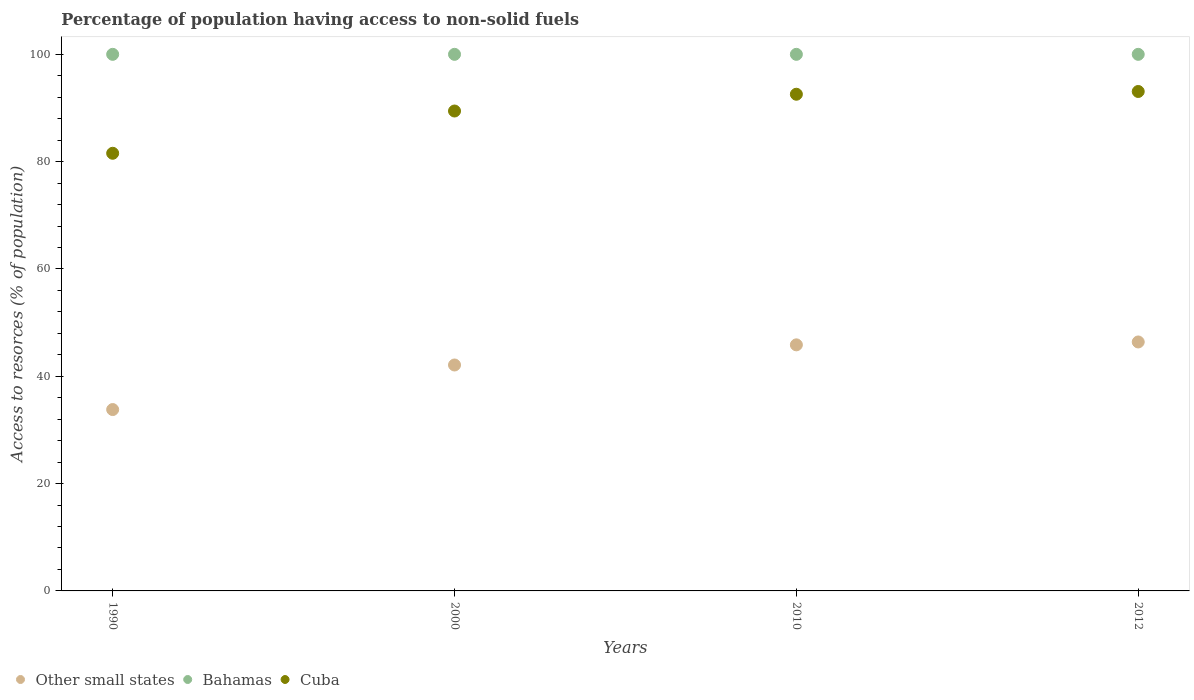Is the number of dotlines equal to the number of legend labels?
Your answer should be very brief. Yes. What is the percentage of population having access to non-solid fuels in Other small states in 1990?
Make the answer very short. 33.8. Across all years, what is the maximum percentage of population having access to non-solid fuels in Other small states?
Make the answer very short. 46.4. Across all years, what is the minimum percentage of population having access to non-solid fuels in Other small states?
Make the answer very short. 33.8. What is the total percentage of population having access to non-solid fuels in Other small states in the graph?
Provide a short and direct response. 168.16. What is the difference between the percentage of population having access to non-solid fuels in Bahamas in 1990 and that in 2010?
Your response must be concise. 0. What is the difference between the percentage of population having access to non-solid fuels in Bahamas in 2000 and the percentage of population having access to non-solid fuels in Cuba in 2010?
Your answer should be compact. 7.44. What is the average percentage of population having access to non-solid fuels in Bahamas per year?
Give a very brief answer. 100. In the year 2012, what is the difference between the percentage of population having access to non-solid fuels in Cuba and percentage of population having access to non-solid fuels in Other small states?
Provide a short and direct response. 46.68. What is the ratio of the percentage of population having access to non-solid fuels in Cuba in 2000 to that in 2010?
Offer a very short reply. 0.97. Is the percentage of population having access to non-solid fuels in Other small states in 1990 less than that in 2000?
Offer a terse response. Yes. What is the difference between the highest and the second highest percentage of population having access to non-solid fuels in Cuba?
Ensure brevity in your answer.  0.51. What is the difference between the highest and the lowest percentage of population having access to non-solid fuels in Bahamas?
Your answer should be very brief. 0. Is the sum of the percentage of population having access to non-solid fuels in Other small states in 2000 and 2010 greater than the maximum percentage of population having access to non-solid fuels in Bahamas across all years?
Your answer should be very brief. No. How many dotlines are there?
Offer a terse response. 3. What is the difference between two consecutive major ticks on the Y-axis?
Your response must be concise. 20. Are the values on the major ticks of Y-axis written in scientific E-notation?
Your answer should be compact. No. Does the graph contain any zero values?
Give a very brief answer. No. Does the graph contain grids?
Make the answer very short. No. Where does the legend appear in the graph?
Your answer should be compact. Bottom left. What is the title of the graph?
Your answer should be compact. Percentage of population having access to non-solid fuels. What is the label or title of the Y-axis?
Offer a terse response. Access to resorces (% of population). What is the Access to resorces (% of population) of Other small states in 1990?
Your response must be concise. 33.8. What is the Access to resorces (% of population) in Cuba in 1990?
Provide a short and direct response. 81.56. What is the Access to resorces (% of population) in Other small states in 2000?
Offer a terse response. 42.11. What is the Access to resorces (% of population) of Bahamas in 2000?
Provide a short and direct response. 100. What is the Access to resorces (% of population) of Cuba in 2000?
Ensure brevity in your answer.  89.44. What is the Access to resorces (% of population) of Other small states in 2010?
Ensure brevity in your answer.  45.86. What is the Access to resorces (% of population) of Bahamas in 2010?
Your answer should be compact. 100. What is the Access to resorces (% of population) of Cuba in 2010?
Your answer should be very brief. 92.56. What is the Access to resorces (% of population) in Other small states in 2012?
Offer a terse response. 46.4. What is the Access to resorces (% of population) in Bahamas in 2012?
Provide a short and direct response. 100. What is the Access to resorces (% of population) of Cuba in 2012?
Make the answer very short. 93.08. Across all years, what is the maximum Access to resorces (% of population) of Other small states?
Ensure brevity in your answer.  46.4. Across all years, what is the maximum Access to resorces (% of population) of Bahamas?
Keep it short and to the point. 100. Across all years, what is the maximum Access to resorces (% of population) in Cuba?
Offer a terse response. 93.08. Across all years, what is the minimum Access to resorces (% of population) of Other small states?
Your response must be concise. 33.8. Across all years, what is the minimum Access to resorces (% of population) of Bahamas?
Ensure brevity in your answer.  100. Across all years, what is the minimum Access to resorces (% of population) in Cuba?
Your response must be concise. 81.56. What is the total Access to resorces (% of population) in Other small states in the graph?
Provide a short and direct response. 168.16. What is the total Access to resorces (% of population) of Cuba in the graph?
Your answer should be very brief. 356.64. What is the difference between the Access to resorces (% of population) of Other small states in 1990 and that in 2000?
Your answer should be very brief. -8.31. What is the difference between the Access to resorces (% of population) in Bahamas in 1990 and that in 2000?
Keep it short and to the point. 0. What is the difference between the Access to resorces (% of population) of Cuba in 1990 and that in 2000?
Keep it short and to the point. -7.88. What is the difference between the Access to resorces (% of population) in Other small states in 1990 and that in 2010?
Make the answer very short. -12.06. What is the difference between the Access to resorces (% of population) of Cuba in 1990 and that in 2010?
Provide a succinct answer. -11. What is the difference between the Access to resorces (% of population) of Other small states in 1990 and that in 2012?
Ensure brevity in your answer.  -12.6. What is the difference between the Access to resorces (% of population) of Cuba in 1990 and that in 2012?
Provide a short and direct response. -11.52. What is the difference between the Access to resorces (% of population) in Other small states in 2000 and that in 2010?
Give a very brief answer. -3.75. What is the difference between the Access to resorces (% of population) of Cuba in 2000 and that in 2010?
Provide a succinct answer. -3.13. What is the difference between the Access to resorces (% of population) of Other small states in 2000 and that in 2012?
Offer a terse response. -4.29. What is the difference between the Access to resorces (% of population) in Bahamas in 2000 and that in 2012?
Provide a short and direct response. 0. What is the difference between the Access to resorces (% of population) of Cuba in 2000 and that in 2012?
Your answer should be very brief. -3.64. What is the difference between the Access to resorces (% of population) in Other small states in 2010 and that in 2012?
Your answer should be compact. -0.54. What is the difference between the Access to resorces (% of population) in Bahamas in 2010 and that in 2012?
Ensure brevity in your answer.  0. What is the difference between the Access to resorces (% of population) in Cuba in 2010 and that in 2012?
Offer a terse response. -0.51. What is the difference between the Access to resorces (% of population) in Other small states in 1990 and the Access to resorces (% of population) in Bahamas in 2000?
Offer a very short reply. -66.2. What is the difference between the Access to resorces (% of population) of Other small states in 1990 and the Access to resorces (% of population) of Cuba in 2000?
Ensure brevity in your answer.  -55.64. What is the difference between the Access to resorces (% of population) in Bahamas in 1990 and the Access to resorces (% of population) in Cuba in 2000?
Provide a succinct answer. 10.56. What is the difference between the Access to resorces (% of population) in Other small states in 1990 and the Access to resorces (% of population) in Bahamas in 2010?
Make the answer very short. -66.2. What is the difference between the Access to resorces (% of population) of Other small states in 1990 and the Access to resorces (% of population) of Cuba in 2010?
Ensure brevity in your answer.  -58.76. What is the difference between the Access to resorces (% of population) of Bahamas in 1990 and the Access to resorces (% of population) of Cuba in 2010?
Your response must be concise. 7.44. What is the difference between the Access to resorces (% of population) of Other small states in 1990 and the Access to resorces (% of population) of Bahamas in 2012?
Provide a short and direct response. -66.2. What is the difference between the Access to resorces (% of population) of Other small states in 1990 and the Access to resorces (% of population) of Cuba in 2012?
Your answer should be compact. -59.28. What is the difference between the Access to resorces (% of population) of Bahamas in 1990 and the Access to resorces (% of population) of Cuba in 2012?
Ensure brevity in your answer.  6.92. What is the difference between the Access to resorces (% of population) of Other small states in 2000 and the Access to resorces (% of population) of Bahamas in 2010?
Provide a succinct answer. -57.89. What is the difference between the Access to resorces (% of population) of Other small states in 2000 and the Access to resorces (% of population) of Cuba in 2010?
Provide a short and direct response. -50.46. What is the difference between the Access to resorces (% of population) in Bahamas in 2000 and the Access to resorces (% of population) in Cuba in 2010?
Give a very brief answer. 7.44. What is the difference between the Access to resorces (% of population) in Other small states in 2000 and the Access to resorces (% of population) in Bahamas in 2012?
Make the answer very short. -57.89. What is the difference between the Access to resorces (% of population) in Other small states in 2000 and the Access to resorces (% of population) in Cuba in 2012?
Provide a succinct answer. -50.97. What is the difference between the Access to resorces (% of population) of Bahamas in 2000 and the Access to resorces (% of population) of Cuba in 2012?
Give a very brief answer. 6.92. What is the difference between the Access to resorces (% of population) in Other small states in 2010 and the Access to resorces (% of population) in Bahamas in 2012?
Provide a short and direct response. -54.14. What is the difference between the Access to resorces (% of population) of Other small states in 2010 and the Access to resorces (% of population) of Cuba in 2012?
Give a very brief answer. -47.22. What is the difference between the Access to resorces (% of population) of Bahamas in 2010 and the Access to resorces (% of population) of Cuba in 2012?
Make the answer very short. 6.92. What is the average Access to resorces (% of population) of Other small states per year?
Your answer should be very brief. 42.04. What is the average Access to resorces (% of population) in Cuba per year?
Make the answer very short. 89.16. In the year 1990, what is the difference between the Access to resorces (% of population) of Other small states and Access to resorces (% of population) of Bahamas?
Offer a very short reply. -66.2. In the year 1990, what is the difference between the Access to resorces (% of population) in Other small states and Access to resorces (% of population) in Cuba?
Offer a very short reply. -47.76. In the year 1990, what is the difference between the Access to resorces (% of population) in Bahamas and Access to resorces (% of population) in Cuba?
Provide a short and direct response. 18.44. In the year 2000, what is the difference between the Access to resorces (% of population) in Other small states and Access to resorces (% of population) in Bahamas?
Offer a terse response. -57.89. In the year 2000, what is the difference between the Access to resorces (% of population) in Other small states and Access to resorces (% of population) in Cuba?
Ensure brevity in your answer.  -47.33. In the year 2000, what is the difference between the Access to resorces (% of population) in Bahamas and Access to resorces (% of population) in Cuba?
Offer a terse response. 10.56. In the year 2010, what is the difference between the Access to resorces (% of population) of Other small states and Access to resorces (% of population) of Bahamas?
Offer a terse response. -54.14. In the year 2010, what is the difference between the Access to resorces (% of population) of Other small states and Access to resorces (% of population) of Cuba?
Your answer should be very brief. -46.7. In the year 2010, what is the difference between the Access to resorces (% of population) in Bahamas and Access to resorces (% of population) in Cuba?
Offer a terse response. 7.44. In the year 2012, what is the difference between the Access to resorces (% of population) of Other small states and Access to resorces (% of population) of Bahamas?
Provide a succinct answer. -53.6. In the year 2012, what is the difference between the Access to resorces (% of population) of Other small states and Access to resorces (% of population) of Cuba?
Your answer should be very brief. -46.68. In the year 2012, what is the difference between the Access to resorces (% of population) in Bahamas and Access to resorces (% of population) in Cuba?
Ensure brevity in your answer.  6.92. What is the ratio of the Access to resorces (% of population) of Other small states in 1990 to that in 2000?
Your answer should be compact. 0.8. What is the ratio of the Access to resorces (% of population) of Bahamas in 1990 to that in 2000?
Provide a short and direct response. 1. What is the ratio of the Access to resorces (% of population) in Cuba in 1990 to that in 2000?
Offer a very short reply. 0.91. What is the ratio of the Access to resorces (% of population) of Other small states in 1990 to that in 2010?
Offer a terse response. 0.74. What is the ratio of the Access to resorces (% of population) of Cuba in 1990 to that in 2010?
Provide a short and direct response. 0.88. What is the ratio of the Access to resorces (% of population) in Other small states in 1990 to that in 2012?
Offer a very short reply. 0.73. What is the ratio of the Access to resorces (% of population) of Bahamas in 1990 to that in 2012?
Give a very brief answer. 1. What is the ratio of the Access to resorces (% of population) in Cuba in 1990 to that in 2012?
Ensure brevity in your answer.  0.88. What is the ratio of the Access to resorces (% of population) of Other small states in 2000 to that in 2010?
Ensure brevity in your answer.  0.92. What is the ratio of the Access to resorces (% of population) of Cuba in 2000 to that in 2010?
Provide a succinct answer. 0.97. What is the ratio of the Access to resorces (% of population) in Other small states in 2000 to that in 2012?
Ensure brevity in your answer.  0.91. What is the ratio of the Access to resorces (% of population) of Cuba in 2000 to that in 2012?
Offer a very short reply. 0.96. What is the ratio of the Access to resorces (% of population) of Other small states in 2010 to that in 2012?
Offer a terse response. 0.99. What is the ratio of the Access to resorces (% of population) of Bahamas in 2010 to that in 2012?
Offer a very short reply. 1. What is the ratio of the Access to resorces (% of population) in Cuba in 2010 to that in 2012?
Ensure brevity in your answer.  0.99. What is the difference between the highest and the second highest Access to resorces (% of population) of Other small states?
Your answer should be very brief. 0.54. What is the difference between the highest and the second highest Access to resorces (% of population) in Bahamas?
Make the answer very short. 0. What is the difference between the highest and the second highest Access to resorces (% of population) in Cuba?
Provide a succinct answer. 0.51. What is the difference between the highest and the lowest Access to resorces (% of population) in Other small states?
Provide a succinct answer. 12.6. What is the difference between the highest and the lowest Access to resorces (% of population) of Cuba?
Make the answer very short. 11.52. 